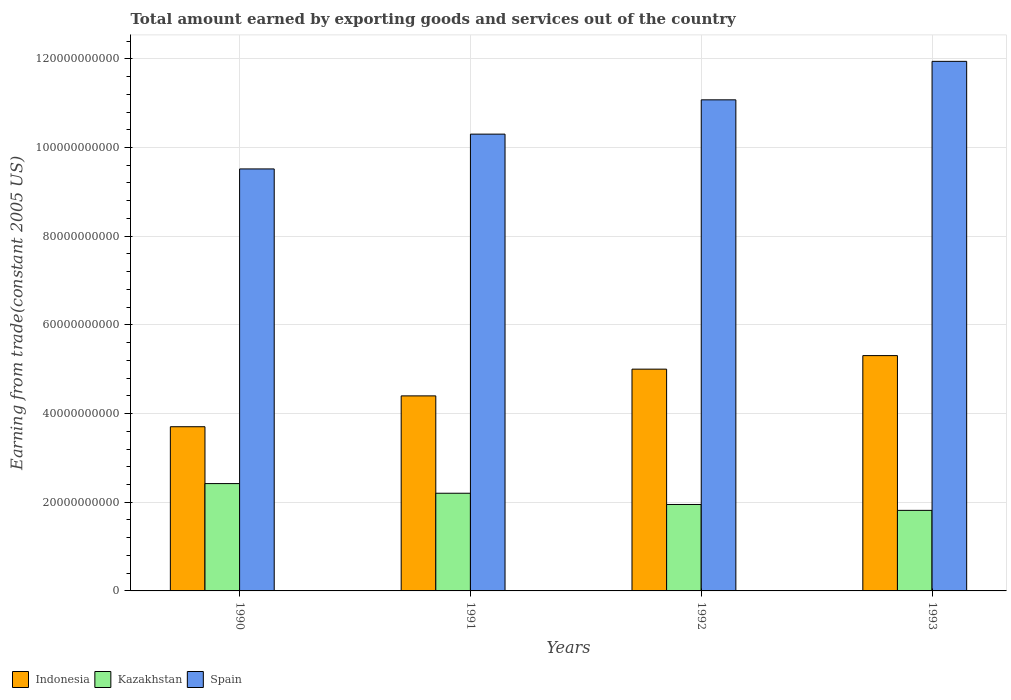How many groups of bars are there?
Ensure brevity in your answer.  4. Are the number of bars per tick equal to the number of legend labels?
Offer a very short reply. Yes. Are the number of bars on each tick of the X-axis equal?
Your answer should be compact. Yes. How many bars are there on the 2nd tick from the right?
Your answer should be very brief. 3. In how many cases, is the number of bars for a given year not equal to the number of legend labels?
Your response must be concise. 0. What is the total amount earned by exporting goods and services in Kazakhstan in 1992?
Your response must be concise. 1.95e+1. Across all years, what is the maximum total amount earned by exporting goods and services in Indonesia?
Give a very brief answer. 5.31e+1. Across all years, what is the minimum total amount earned by exporting goods and services in Spain?
Keep it short and to the point. 9.52e+1. In which year was the total amount earned by exporting goods and services in Kazakhstan maximum?
Your answer should be very brief. 1990. What is the total total amount earned by exporting goods and services in Indonesia in the graph?
Offer a terse response. 1.84e+11. What is the difference between the total amount earned by exporting goods and services in Spain in 1990 and that in 1993?
Make the answer very short. -2.43e+1. What is the difference between the total amount earned by exporting goods and services in Spain in 1993 and the total amount earned by exporting goods and services in Kazakhstan in 1990?
Give a very brief answer. 9.52e+1. What is the average total amount earned by exporting goods and services in Kazakhstan per year?
Keep it short and to the point. 2.10e+1. In the year 1993, what is the difference between the total amount earned by exporting goods and services in Indonesia and total amount earned by exporting goods and services in Spain?
Your answer should be compact. -6.64e+1. What is the ratio of the total amount earned by exporting goods and services in Spain in 1990 to that in 1993?
Keep it short and to the point. 0.8. Is the difference between the total amount earned by exporting goods and services in Indonesia in 1991 and 1992 greater than the difference between the total amount earned by exporting goods and services in Spain in 1991 and 1992?
Your answer should be very brief. Yes. What is the difference between the highest and the second highest total amount earned by exporting goods and services in Spain?
Your response must be concise. 8.68e+09. What is the difference between the highest and the lowest total amount earned by exporting goods and services in Kazakhstan?
Provide a succinct answer. 6.04e+09. In how many years, is the total amount earned by exporting goods and services in Kazakhstan greater than the average total amount earned by exporting goods and services in Kazakhstan taken over all years?
Provide a short and direct response. 2. Is the sum of the total amount earned by exporting goods and services in Indonesia in 1990 and 1992 greater than the maximum total amount earned by exporting goods and services in Kazakhstan across all years?
Offer a very short reply. Yes. What does the 2nd bar from the left in 1993 represents?
Give a very brief answer. Kazakhstan. What does the 2nd bar from the right in 1992 represents?
Keep it short and to the point. Kazakhstan. How many years are there in the graph?
Offer a very short reply. 4. Are the values on the major ticks of Y-axis written in scientific E-notation?
Give a very brief answer. No. Where does the legend appear in the graph?
Offer a terse response. Bottom left. How are the legend labels stacked?
Give a very brief answer. Horizontal. What is the title of the graph?
Offer a terse response. Total amount earned by exporting goods and services out of the country. Does "Jordan" appear as one of the legend labels in the graph?
Offer a terse response. No. What is the label or title of the X-axis?
Offer a terse response. Years. What is the label or title of the Y-axis?
Make the answer very short. Earning from trade(constant 2005 US). What is the Earning from trade(constant 2005 US) in Indonesia in 1990?
Offer a very short reply. 3.70e+1. What is the Earning from trade(constant 2005 US) of Kazakhstan in 1990?
Offer a terse response. 2.42e+1. What is the Earning from trade(constant 2005 US) in Spain in 1990?
Ensure brevity in your answer.  9.52e+1. What is the Earning from trade(constant 2005 US) in Indonesia in 1991?
Provide a short and direct response. 4.40e+1. What is the Earning from trade(constant 2005 US) in Kazakhstan in 1991?
Ensure brevity in your answer.  2.20e+1. What is the Earning from trade(constant 2005 US) of Spain in 1991?
Make the answer very short. 1.03e+11. What is the Earning from trade(constant 2005 US) in Indonesia in 1992?
Provide a succinct answer. 5.00e+1. What is the Earning from trade(constant 2005 US) of Kazakhstan in 1992?
Ensure brevity in your answer.  1.95e+1. What is the Earning from trade(constant 2005 US) of Spain in 1992?
Provide a succinct answer. 1.11e+11. What is the Earning from trade(constant 2005 US) of Indonesia in 1993?
Provide a short and direct response. 5.31e+1. What is the Earning from trade(constant 2005 US) in Kazakhstan in 1993?
Your answer should be very brief. 1.82e+1. What is the Earning from trade(constant 2005 US) of Spain in 1993?
Your answer should be compact. 1.19e+11. Across all years, what is the maximum Earning from trade(constant 2005 US) in Indonesia?
Your response must be concise. 5.31e+1. Across all years, what is the maximum Earning from trade(constant 2005 US) in Kazakhstan?
Provide a short and direct response. 2.42e+1. Across all years, what is the maximum Earning from trade(constant 2005 US) of Spain?
Provide a short and direct response. 1.19e+11. Across all years, what is the minimum Earning from trade(constant 2005 US) in Indonesia?
Ensure brevity in your answer.  3.70e+1. Across all years, what is the minimum Earning from trade(constant 2005 US) in Kazakhstan?
Your answer should be compact. 1.82e+1. Across all years, what is the minimum Earning from trade(constant 2005 US) in Spain?
Offer a terse response. 9.52e+1. What is the total Earning from trade(constant 2005 US) in Indonesia in the graph?
Your answer should be compact. 1.84e+11. What is the total Earning from trade(constant 2005 US) of Kazakhstan in the graph?
Give a very brief answer. 8.39e+1. What is the total Earning from trade(constant 2005 US) in Spain in the graph?
Ensure brevity in your answer.  4.28e+11. What is the difference between the Earning from trade(constant 2005 US) of Indonesia in 1990 and that in 1991?
Your answer should be compact. -6.95e+09. What is the difference between the Earning from trade(constant 2005 US) in Kazakhstan in 1990 and that in 1991?
Make the answer very short. 2.18e+09. What is the difference between the Earning from trade(constant 2005 US) of Spain in 1990 and that in 1991?
Ensure brevity in your answer.  -7.85e+09. What is the difference between the Earning from trade(constant 2005 US) of Indonesia in 1990 and that in 1992?
Offer a very short reply. -1.30e+1. What is the difference between the Earning from trade(constant 2005 US) in Kazakhstan in 1990 and that in 1992?
Provide a short and direct response. 4.71e+09. What is the difference between the Earning from trade(constant 2005 US) in Spain in 1990 and that in 1992?
Your response must be concise. -1.56e+1. What is the difference between the Earning from trade(constant 2005 US) in Indonesia in 1990 and that in 1993?
Offer a very short reply. -1.60e+1. What is the difference between the Earning from trade(constant 2005 US) in Kazakhstan in 1990 and that in 1993?
Your answer should be compact. 6.04e+09. What is the difference between the Earning from trade(constant 2005 US) of Spain in 1990 and that in 1993?
Give a very brief answer. -2.43e+1. What is the difference between the Earning from trade(constant 2005 US) in Indonesia in 1991 and that in 1992?
Provide a short and direct response. -6.03e+09. What is the difference between the Earning from trade(constant 2005 US) of Kazakhstan in 1991 and that in 1992?
Your answer should be very brief. 2.53e+09. What is the difference between the Earning from trade(constant 2005 US) of Spain in 1991 and that in 1992?
Ensure brevity in your answer.  -7.73e+09. What is the difference between the Earning from trade(constant 2005 US) of Indonesia in 1991 and that in 1993?
Ensure brevity in your answer.  -9.08e+09. What is the difference between the Earning from trade(constant 2005 US) in Kazakhstan in 1991 and that in 1993?
Keep it short and to the point. 3.86e+09. What is the difference between the Earning from trade(constant 2005 US) of Spain in 1991 and that in 1993?
Offer a very short reply. -1.64e+1. What is the difference between the Earning from trade(constant 2005 US) of Indonesia in 1992 and that in 1993?
Your response must be concise. -3.05e+09. What is the difference between the Earning from trade(constant 2005 US) in Kazakhstan in 1992 and that in 1993?
Offer a very short reply. 1.33e+09. What is the difference between the Earning from trade(constant 2005 US) of Spain in 1992 and that in 1993?
Ensure brevity in your answer.  -8.68e+09. What is the difference between the Earning from trade(constant 2005 US) of Indonesia in 1990 and the Earning from trade(constant 2005 US) of Kazakhstan in 1991?
Your response must be concise. 1.50e+1. What is the difference between the Earning from trade(constant 2005 US) of Indonesia in 1990 and the Earning from trade(constant 2005 US) of Spain in 1991?
Offer a terse response. -6.60e+1. What is the difference between the Earning from trade(constant 2005 US) in Kazakhstan in 1990 and the Earning from trade(constant 2005 US) in Spain in 1991?
Provide a short and direct response. -7.88e+1. What is the difference between the Earning from trade(constant 2005 US) of Indonesia in 1990 and the Earning from trade(constant 2005 US) of Kazakhstan in 1992?
Keep it short and to the point. 1.75e+1. What is the difference between the Earning from trade(constant 2005 US) of Indonesia in 1990 and the Earning from trade(constant 2005 US) of Spain in 1992?
Keep it short and to the point. -7.37e+1. What is the difference between the Earning from trade(constant 2005 US) of Kazakhstan in 1990 and the Earning from trade(constant 2005 US) of Spain in 1992?
Offer a terse response. -8.65e+1. What is the difference between the Earning from trade(constant 2005 US) of Indonesia in 1990 and the Earning from trade(constant 2005 US) of Kazakhstan in 1993?
Your response must be concise. 1.89e+1. What is the difference between the Earning from trade(constant 2005 US) in Indonesia in 1990 and the Earning from trade(constant 2005 US) in Spain in 1993?
Offer a very short reply. -8.24e+1. What is the difference between the Earning from trade(constant 2005 US) of Kazakhstan in 1990 and the Earning from trade(constant 2005 US) of Spain in 1993?
Ensure brevity in your answer.  -9.52e+1. What is the difference between the Earning from trade(constant 2005 US) of Indonesia in 1991 and the Earning from trade(constant 2005 US) of Kazakhstan in 1992?
Make the answer very short. 2.45e+1. What is the difference between the Earning from trade(constant 2005 US) of Indonesia in 1991 and the Earning from trade(constant 2005 US) of Spain in 1992?
Your response must be concise. -6.68e+1. What is the difference between the Earning from trade(constant 2005 US) in Kazakhstan in 1991 and the Earning from trade(constant 2005 US) in Spain in 1992?
Your answer should be very brief. -8.87e+1. What is the difference between the Earning from trade(constant 2005 US) of Indonesia in 1991 and the Earning from trade(constant 2005 US) of Kazakhstan in 1993?
Ensure brevity in your answer.  2.58e+1. What is the difference between the Earning from trade(constant 2005 US) in Indonesia in 1991 and the Earning from trade(constant 2005 US) in Spain in 1993?
Your response must be concise. -7.54e+1. What is the difference between the Earning from trade(constant 2005 US) of Kazakhstan in 1991 and the Earning from trade(constant 2005 US) of Spain in 1993?
Offer a terse response. -9.74e+1. What is the difference between the Earning from trade(constant 2005 US) in Indonesia in 1992 and the Earning from trade(constant 2005 US) in Kazakhstan in 1993?
Offer a very short reply. 3.18e+1. What is the difference between the Earning from trade(constant 2005 US) in Indonesia in 1992 and the Earning from trade(constant 2005 US) in Spain in 1993?
Give a very brief answer. -6.94e+1. What is the difference between the Earning from trade(constant 2005 US) in Kazakhstan in 1992 and the Earning from trade(constant 2005 US) in Spain in 1993?
Offer a very short reply. -9.99e+1. What is the average Earning from trade(constant 2005 US) in Indonesia per year?
Make the answer very short. 4.60e+1. What is the average Earning from trade(constant 2005 US) of Kazakhstan per year?
Give a very brief answer. 2.10e+1. What is the average Earning from trade(constant 2005 US) in Spain per year?
Ensure brevity in your answer.  1.07e+11. In the year 1990, what is the difference between the Earning from trade(constant 2005 US) of Indonesia and Earning from trade(constant 2005 US) of Kazakhstan?
Your answer should be compact. 1.28e+1. In the year 1990, what is the difference between the Earning from trade(constant 2005 US) of Indonesia and Earning from trade(constant 2005 US) of Spain?
Give a very brief answer. -5.81e+1. In the year 1990, what is the difference between the Earning from trade(constant 2005 US) in Kazakhstan and Earning from trade(constant 2005 US) in Spain?
Provide a succinct answer. -7.10e+1. In the year 1991, what is the difference between the Earning from trade(constant 2005 US) in Indonesia and Earning from trade(constant 2005 US) in Kazakhstan?
Ensure brevity in your answer.  2.20e+1. In the year 1991, what is the difference between the Earning from trade(constant 2005 US) in Indonesia and Earning from trade(constant 2005 US) in Spain?
Keep it short and to the point. -5.90e+1. In the year 1991, what is the difference between the Earning from trade(constant 2005 US) of Kazakhstan and Earning from trade(constant 2005 US) of Spain?
Offer a terse response. -8.10e+1. In the year 1992, what is the difference between the Earning from trade(constant 2005 US) of Indonesia and Earning from trade(constant 2005 US) of Kazakhstan?
Ensure brevity in your answer.  3.05e+1. In the year 1992, what is the difference between the Earning from trade(constant 2005 US) in Indonesia and Earning from trade(constant 2005 US) in Spain?
Your answer should be very brief. -6.07e+1. In the year 1992, what is the difference between the Earning from trade(constant 2005 US) in Kazakhstan and Earning from trade(constant 2005 US) in Spain?
Make the answer very short. -9.13e+1. In the year 1993, what is the difference between the Earning from trade(constant 2005 US) of Indonesia and Earning from trade(constant 2005 US) of Kazakhstan?
Give a very brief answer. 3.49e+1. In the year 1993, what is the difference between the Earning from trade(constant 2005 US) in Indonesia and Earning from trade(constant 2005 US) in Spain?
Keep it short and to the point. -6.64e+1. In the year 1993, what is the difference between the Earning from trade(constant 2005 US) of Kazakhstan and Earning from trade(constant 2005 US) of Spain?
Your answer should be very brief. -1.01e+11. What is the ratio of the Earning from trade(constant 2005 US) of Indonesia in 1990 to that in 1991?
Your answer should be very brief. 0.84. What is the ratio of the Earning from trade(constant 2005 US) of Kazakhstan in 1990 to that in 1991?
Offer a terse response. 1.1. What is the ratio of the Earning from trade(constant 2005 US) of Spain in 1990 to that in 1991?
Ensure brevity in your answer.  0.92. What is the ratio of the Earning from trade(constant 2005 US) of Indonesia in 1990 to that in 1992?
Ensure brevity in your answer.  0.74. What is the ratio of the Earning from trade(constant 2005 US) in Kazakhstan in 1990 to that in 1992?
Make the answer very short. 1.24. What is the ratio of the Earning from trade(constant 2005 US) in Spain in 1990 to that in 1992?
Your answer should be compact. 0.86. What is the ratio of the Earning from trade(constant 2005 US) in Indonesia in 1990 to that in 1993?
Your response must be concise. 0.7. What is the ratio of the Earning from trade(constant 2005 US) in Kazakhstan in 1990 to that in 1993?
Offer a very short reply. 1.33. What is the ratio of the Earning from trade(constant 2005 US) in Spain in 1990 to that in 1993?
Ensure brevity in your answer.  0.8. What is the ratio of the Earning from trade(constant 2005 US) in Indonesia in 1991 to that in 1992?
Ensure brevity in your answer.  0.88. What is the ratio of the Earning from trade(constant 2005 US) of Kazakhstan in 1991 to that in 1992?
Give a very brief answer. 1.13. What is the ratio of the Earning from trade(constant 2005 US) of Spain in 1991 to that in 1992?
Your answer should be compact. 0.93. What is the ratio of the Earning from trade(constant 2005 US) of Indonesia in 1991 to that in 1993?
Keep it short and to the point. 0.83. What is the ratio of the Earning from trade(constant 2005 US) in Kazakhstan in 1991 to that in 1993?
Provide a succinct answer. 1.21. What is the ratio of the Earning from trade(constant 2005 US) of Spain in 1991 to that in 1993?
Your response must be concise. 0.86. What is the ratio of the Earning from trade(constant 2005 US) in Indonesia in 1992 to that in 1993?
Keep it short and to the point. 0.94. What is the ratio of the Earning from trade(constant 2005 US) in Kazakhstan in 1992 to that in 1993?
Your answer should be very brief. 1.07. What is the ratio of the Earning from trade(constant 2005 US) in Spain in 1992 to that in 1993?
Keep it short and to the point. 0.93. What is the difference between the highest and the second highest Earning from trade(constant 2005 US) in Indonesia?
Your response must be concise. 3.05e+09. What is the difference between the highest and the second highest Earning from trade(constant 2005 US) in Kazakhstan?
Offer a very short reply. 2.18e+09. What is the difference between the highest and the second highest Earning from trade(constant 2005 US) of Spain?
Offer a terse response. 8.68e+09. What is the difference between the highest and the lowest Earning from trade(constant 2005 US) of Indonesia?
Your answer should be very brief. 1.60e+1. What is the difference between the highest and the lowest Earning from trade(constant 2005 US) of Kazakhstan?
Your answer should be compact. 6.04e+09. What is the difference between the highest and the lowest Earning from trade(constant 2005 US) in Spain?
Offer a terse response. 2.43e+1. 